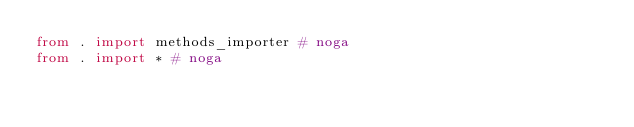<code> <loc_0><loc_0><loc_500><loc_500><_Python_>from . import methods_importer # noga
from . import * # noga</code> 